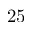<formula> <loc_0><loc_0><loc_500><loc_500>2 5</formula> 